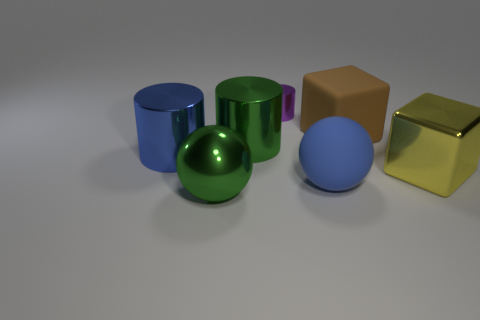Add 1 small gray rubber cubes. How many objects exist? 8 Subtract all spheres. How many objects are left? 5 Add 5 big metal balls. How many big metal balls exist? 6 Subtract 0 cyan spheres. How many objects are left? 7 Subtract all green metal balls. Subtract all large metal cylinders. How many objects are left? 4 Add 6 rubber blocks. How many rubber blocks are left? 7 